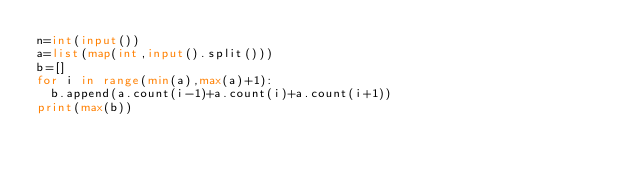<code> <loc_0><loc_0><loc_500><loc_500><_Python_>n=int(input())
a=list(map(int,input().split()))
b=[]
for i in range(min(a),max(a)+1):
  b.append(a.count(i-1)+a.count(i)+a.count(i+1))
print(max(b))</code> 